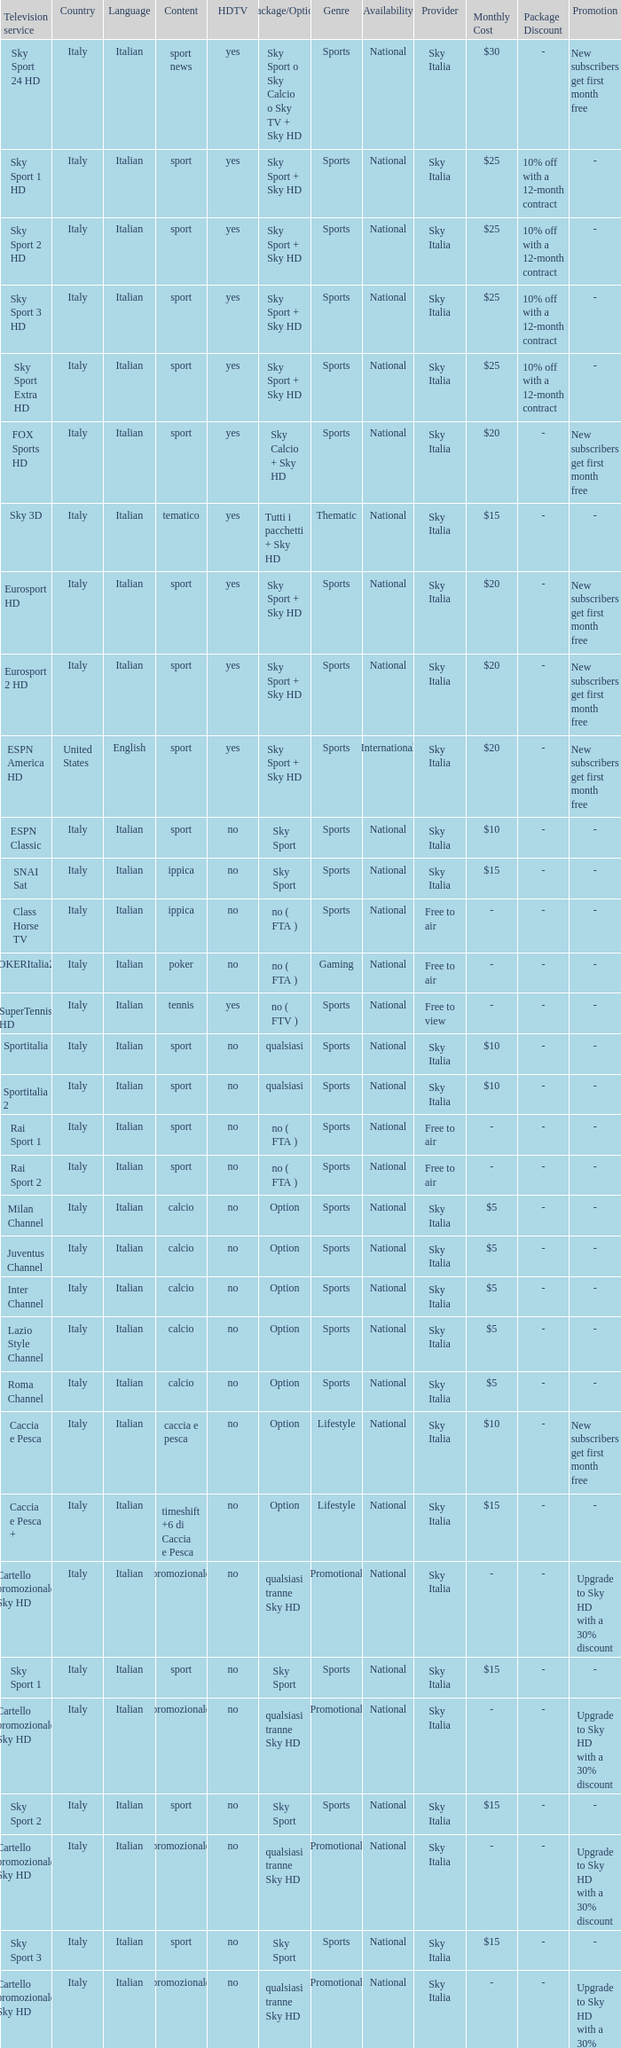What is Package/Option, when Content is Tennis? No ( ftv ). 